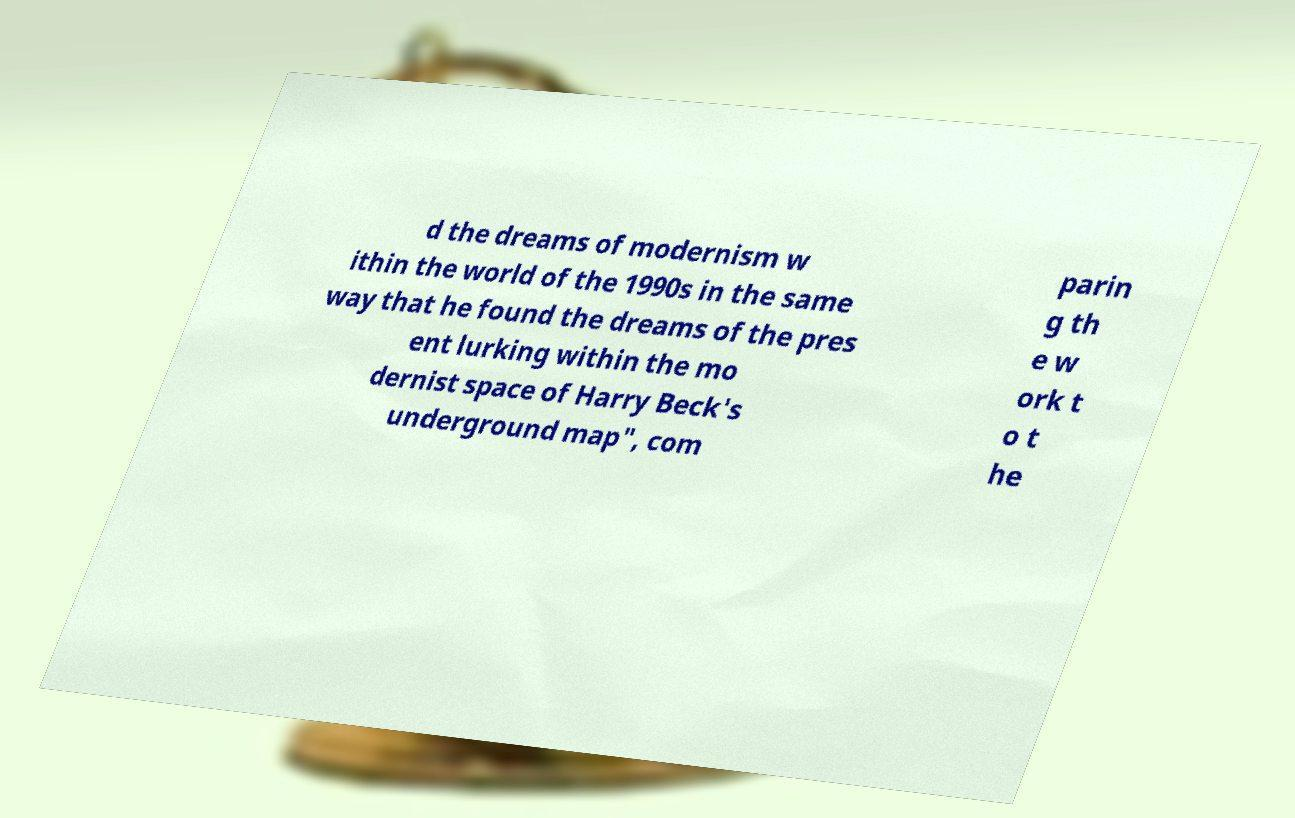Please identify and transcribe the text found in this image. d the dreams of modernism w ithin the world of the 1990s in the same way that he found the dreams of the pres ent lurking within the mo dernist space of Harry Beck's underground map", com parin g th e w ork t o t he 